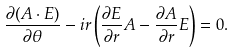<formula> <loc_0><loc_0><loc_500><loc_500>\frac { \partial ( A \cdot E ) } { \partial \theta } - i r \left ( \frac { \partial E } { \partial r } A - \frac { \partial A } { \partial r } E \right ) = 0 .</formula> 